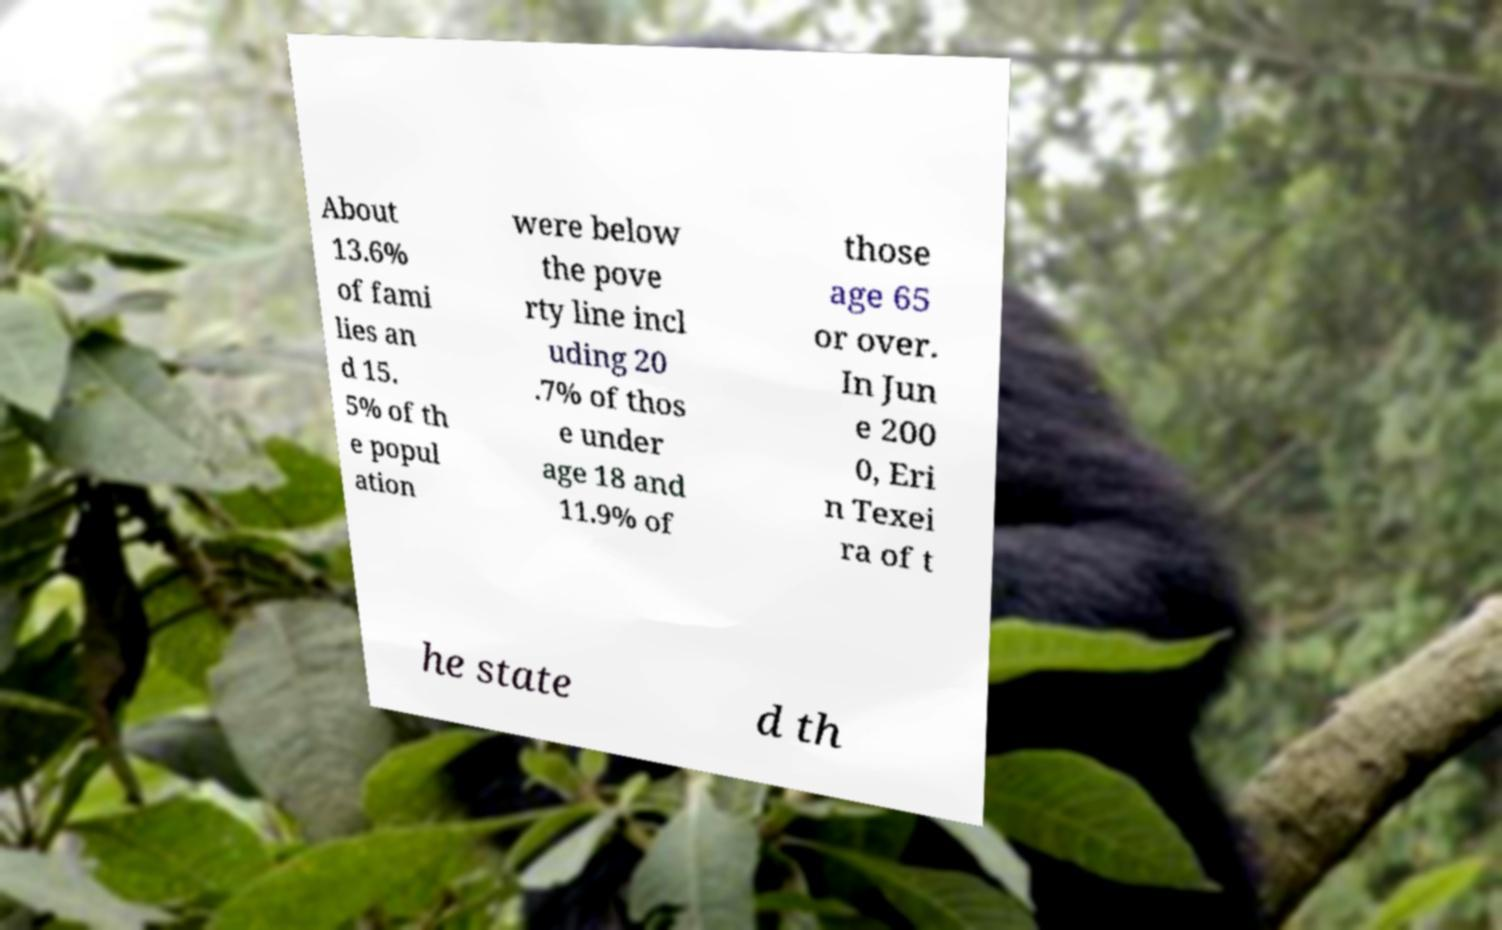Could you extract and type out the text from this image? About 13.6% of fami lies an d 15. 5% of th e popul ation were below the pove rty line incl uding 20 .7% of thos e under age 18 and 11.9% of those age 65 or over. In Jun e 200 0, Eri n Texei ra of t he state d th 